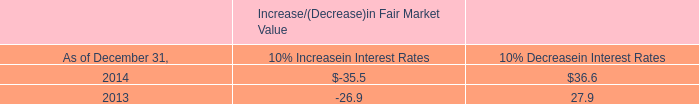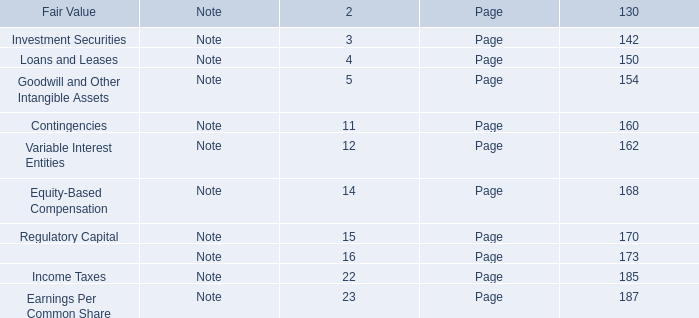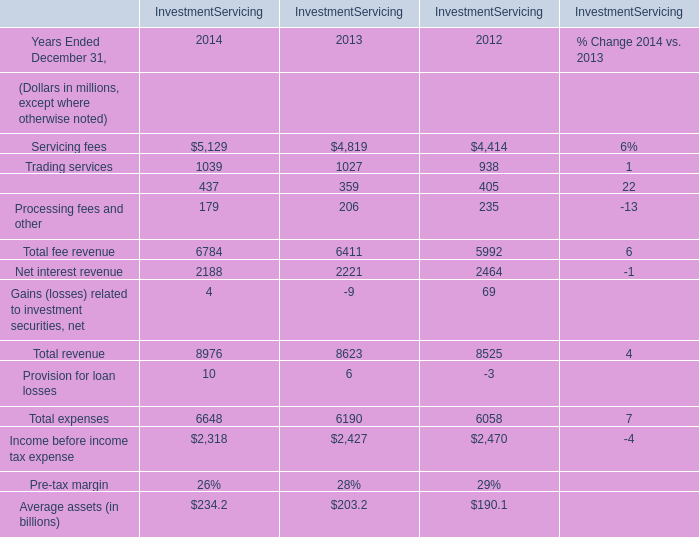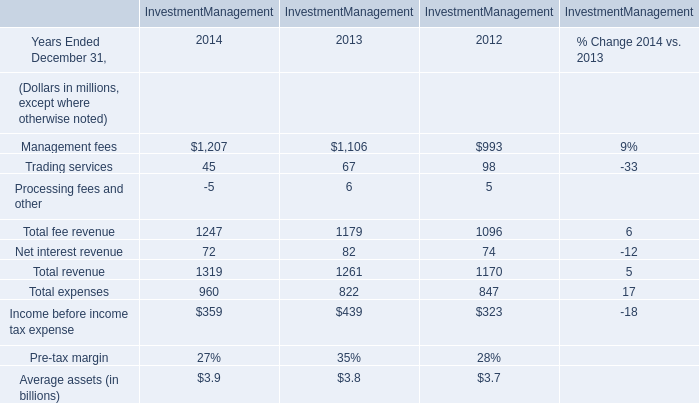assuming that all cash , cash equivalents and marketable securities are invested to generate the stated interest income in 2014 , what would be the average interest rate? 
Computations: (27.4 / 1667.2)
Answer: 0.01643. 